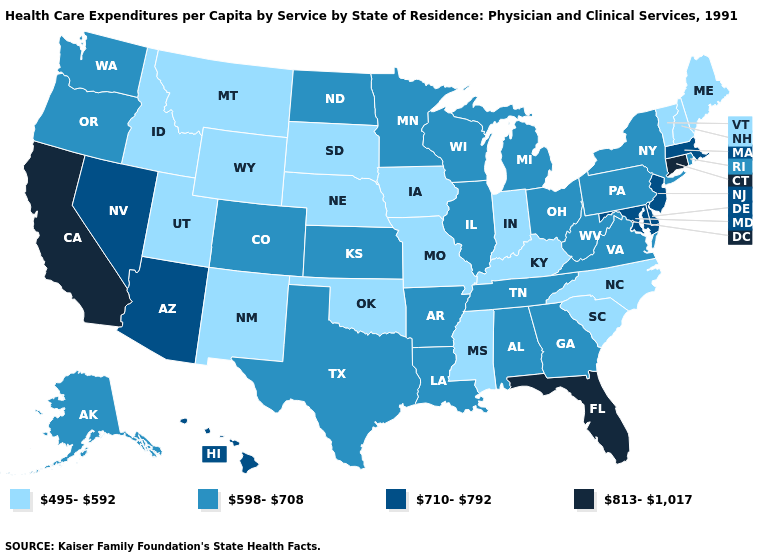How many symbols are there in the legend?
Concise answer only. 4. Among the states that border New York , which have the lowest value?
Concise answer only. Vermont. What is the lowest value in states that border Arizona?
Keep it brief. 495-592. What is the value of North Carolina?
Be succinct. 495-592. What is the value of Illinois?
Concise answer only. 598-708. Does Michigan have the highest value in the USA?
Quick response, please. No. Among the states that border Ohio , which have the highest value?
Short answer required. Michigan, Pennsylvania, West Virginia. What is the value of Pennsylvania?
Give a very brief answer. 598-708. Among the states that border Missouri , which have the lowest value?
Answer briefly. Iowa, Kentucky, Nebraska, Oklahoma. Is the legend a continuous bar?
Be succinct. No. What is the value of Tennessee?
Give a very brief answer. 598-708. Which states hav the highest value in the West?
Keep it brief. California. What is the highest value in the USA?
Write a very short answer. 813-1,017. Name the states that have a value in the range 813-1,017?
Short answer required. California, Connecticut, Florida. Which states have the highest value in the USA?
Write a very short answer. California, Connecticut, Florida. 